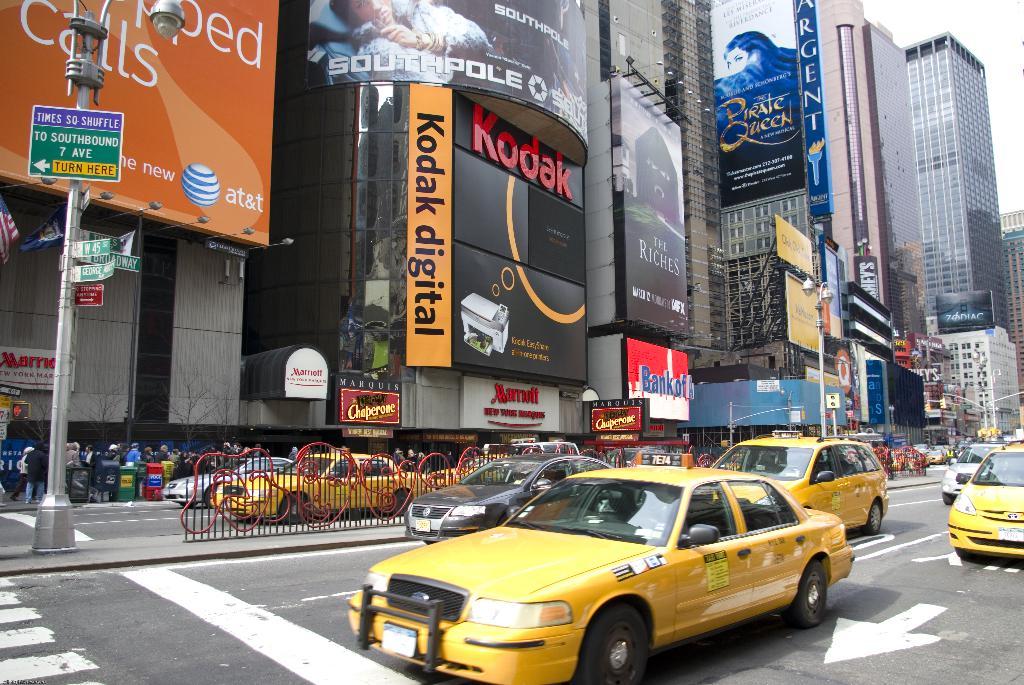What hotel is the kodak sign on?
Provide a succinct answer. Marriott. What is the sign name?
Offer a very short reply. Kodak. 